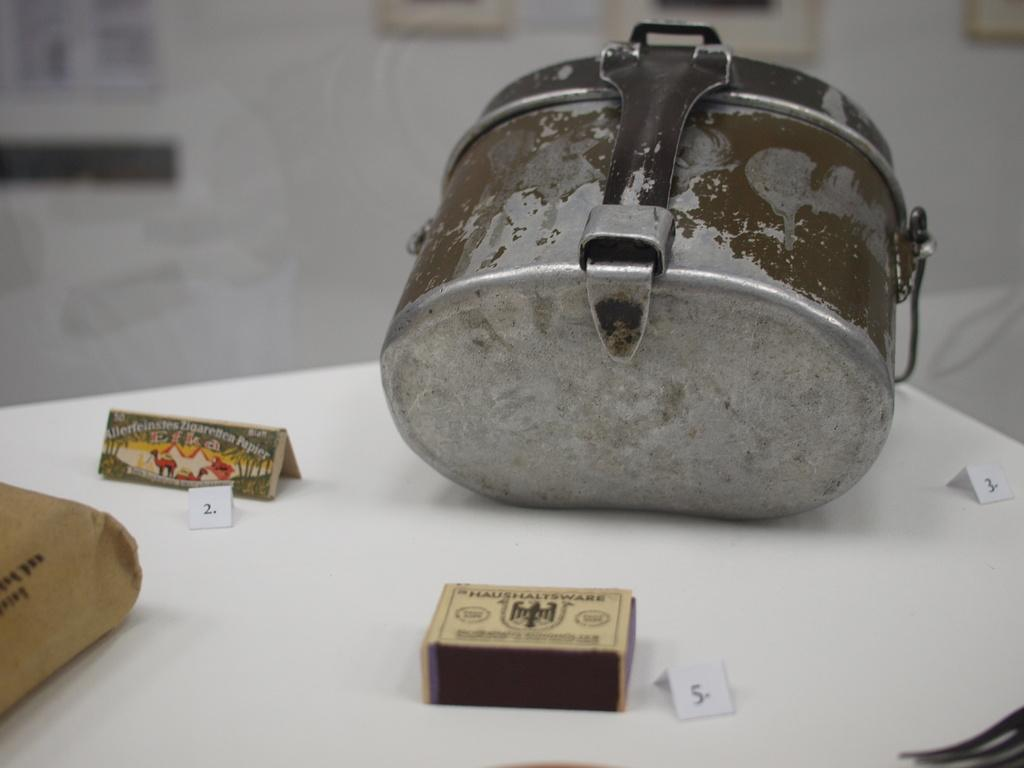What is located at the bottom of the image? There is a table at the bottom of the image. What items can be seen on the table? There are papers and boxes on the table. What is visible behind the table? There is a wall behind the table. What decorative items are on the wall? There are frames on the wall. Is there a woman involved in a war scene depicted in the image? There is no woman or war scene present in the image. Can you see a cart being used to transport goods in the image? There is no cart visible in the image. 